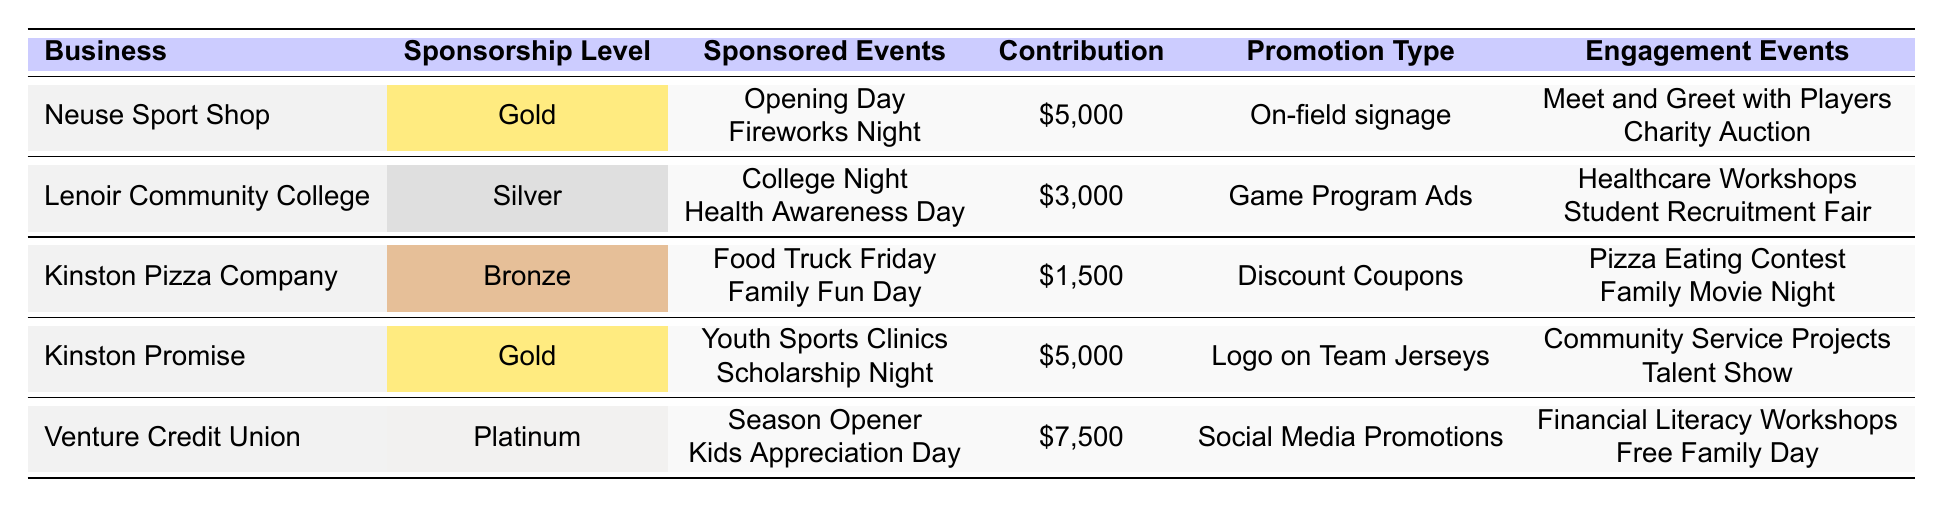What is the highest contribution amount among the businesses? The businesses listed have contribution amounts of $5000, $3000, $1500, $5000, and $7500. The highest of these amounts is $7500, contributed by Venture Credit Union.
Answer: $7500 How many businesses have a Gold sponsorship level? The table shows Neuse Sport Shop and Kinston Promise both have a Gold sponsorship level. Therefore, there are 2 businesses at this level.
Answer: 2 What type of promotion does Kinston Pizza Company provide? Kinston Pizza Company offers Discount Coupons as a promotion type according to the table.
Answer: Discount Coupons Which business sponsored Scholarship Night and what was their contribution amount? Kinston Promise sponsored Scholarship Night and their contribution amount is $5000 as per the table.
Answer: Kinston Promise, $5000 Which business has the lowest contribution amount? The businesses' contributions are $5000, $3000, $1500, $5000, and $7500. The lowest amount is $1500 contributed by Kinston Pizza Company.
Answer: $1500 What is the total contribution amount of Gold-level sponsors? Neuse Sport Shop and Kinston Promise both contribute $5000 each. Adding these amounts gives $5000 + $5000 = $10000 as the total contribution from Gold-level sponsors.
Answer: $10000 Does any business provide social media promotions? The table indicates that Venture Credit Union provides social media promotions, confirming yes to the question.
Answer: Yes Which sponsored event is linked to the most engagement events and what are they? Kinston Promise is associated with 2 engagement events: Community Service Projects and Talent Show. All other businesses have 2 or fewer.
Answer: Kinston Promise; Community Service Projects, Talent Show What are the unique sponsorship levels represented in the table? The table lists the sponsorship levels as Gold, Silver, Bronze, and Platinum. Thus, there are 4 unique sponsorship levels present.
Answer: 4 What is the average contribution amount across all businesses? The contribution amounts are $5000, $3000, $1500, $5000, and $7500. Summing these gives $5000 + $3000 + $1500 + $5000 + $7500 = $22500, and there are 5 businesses. The average is $22500 / 5 = $4500.
Answer: $4500 